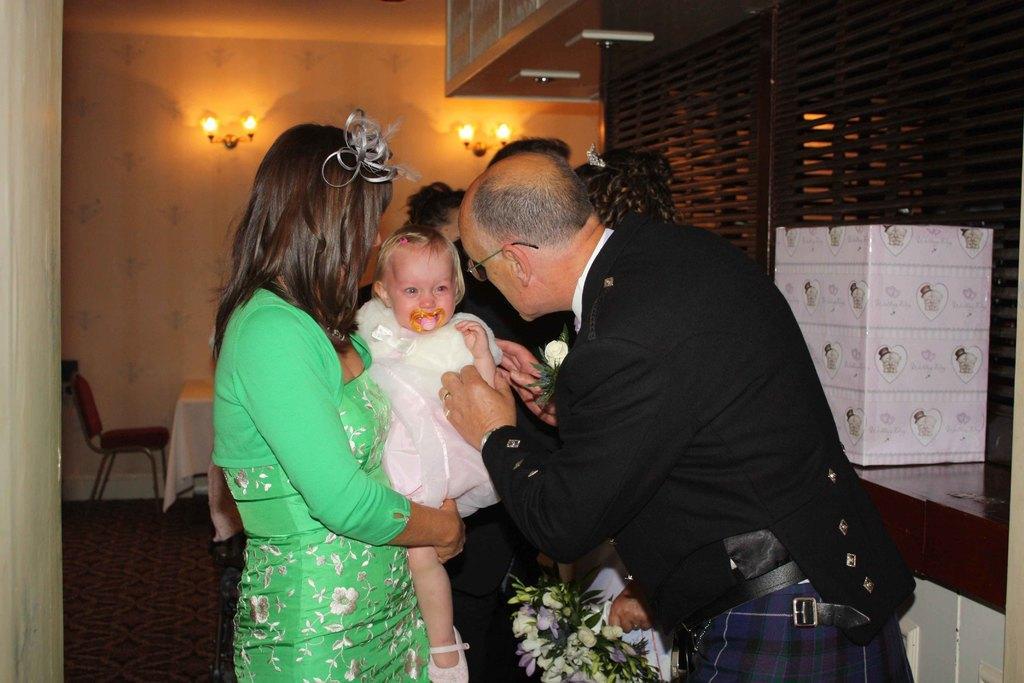How would you summarize this image in a sentence or two? In this picture there are group of person standing. In the center women wearing green colour dress is holding a baby in her hand. At the right side the person is standing and is holding a hand of the baby. In the background the wall, table, chair, lights hanging on the wall. 